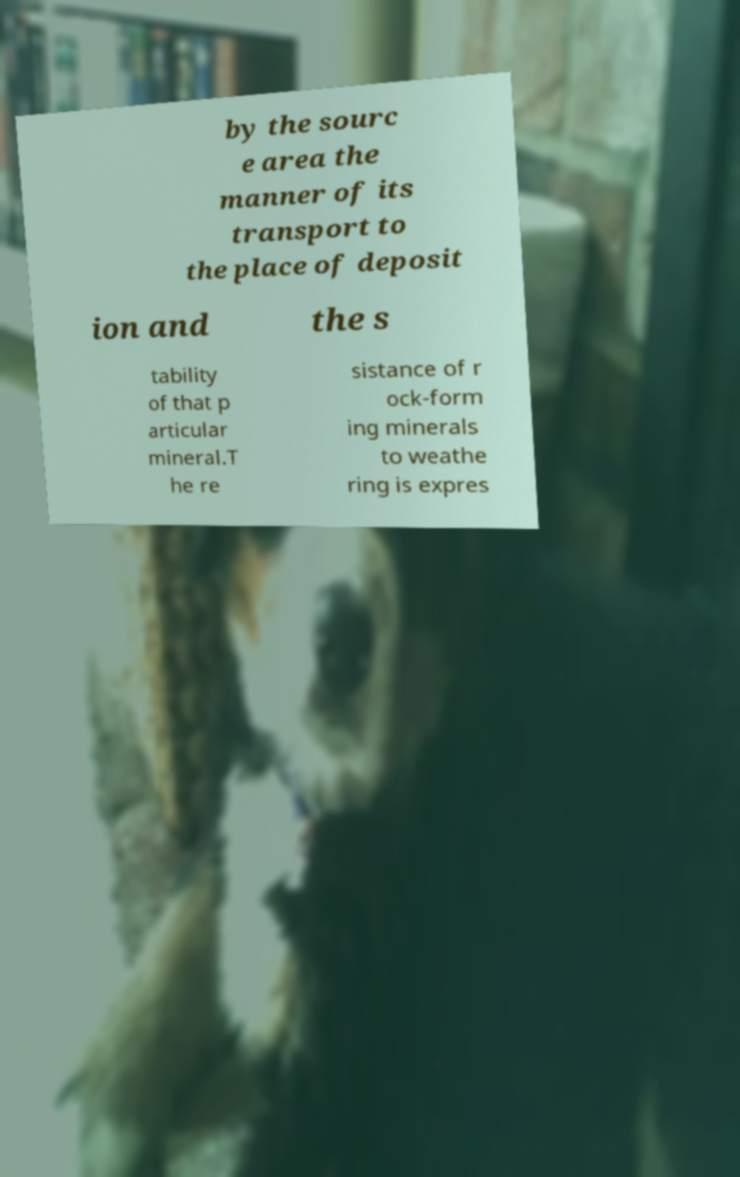Please read and relay the text visible in this image. What does it say? by the sourc e area the manner of its transport to the place of deposit ion and the s tability of that p articular mineral.T he re sistance of r ock-form ing minerals to weathe ring is expres 